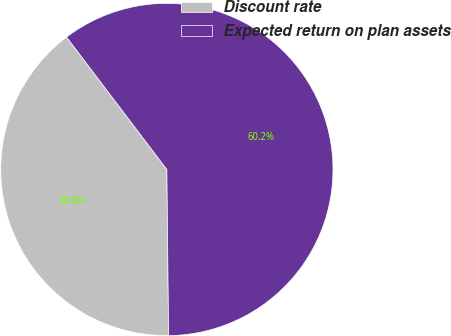Convert chart to OTSL. <chart><loc_0><loc_0><loc_500><loc_500><pie_chart><fcel>Discount rate<fcel>Expected return on plan assets<nl><fcel>39.85%<fcel>60.15%<nl></chart> 